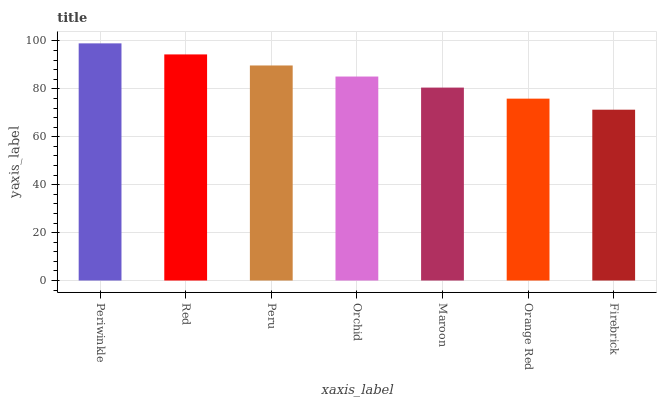Is Firebrick the minimum?
Answer yes or no. Yes. Is Periwinkle the maximum?
Answer yes or no. Yes. Is Red the minimum?
Answer yes or no. No. Is Red the maximum?
Answer yes or no. No. Is Periwinkle greater than Red?
Answer yes or no. Yes. Is Red less than Periwinkle?
Answer yes or no. Yes. Is Red greater than Periwinkle?
Answer yes or no. No. Is Periwinkle less than Red?
Answer yes or no. No. Is Orchid the high median?
Answer yes or no. Yes. Is Orchid the low median?
Answer yes or no. Yes. Is Peru the high median?
Answer yes or no. No. Is Periwinkle the low median?
Answer yes or no. No. 